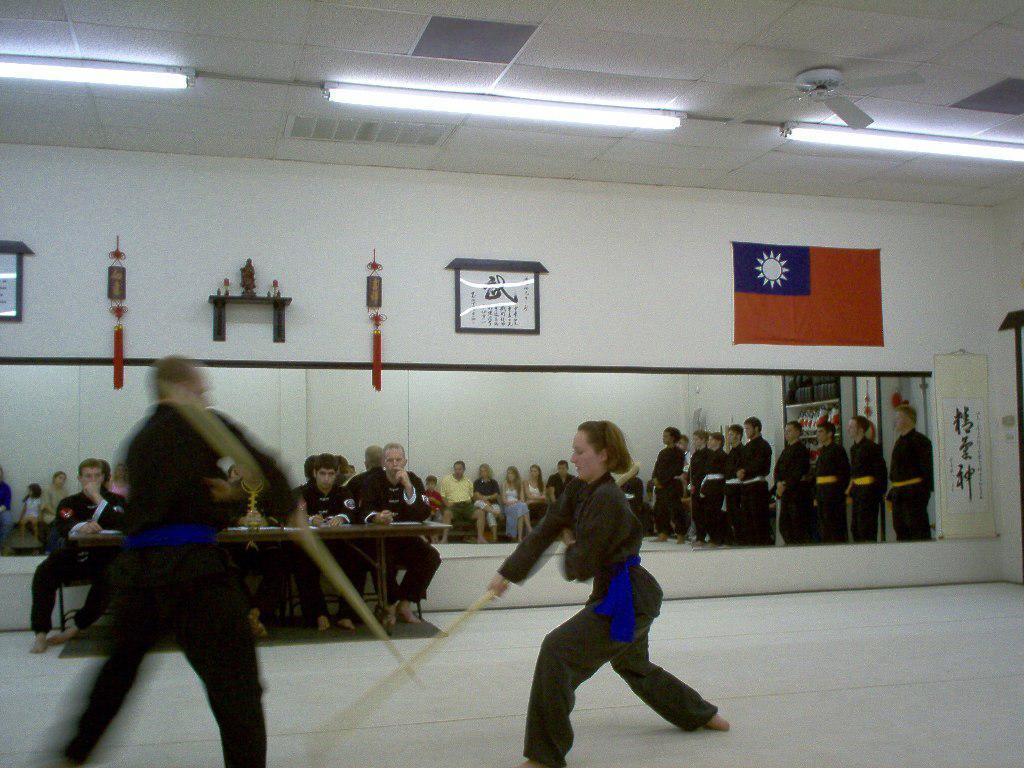How would you summarize this image in a sentence or two? In this image there is a man and a woman holding a stick in their hand are performing a martial art, beside them on the wall there is a mirror, in the mirror, we can see the reflection of a few people standing and sitting, at the top of the mirror there are a few objects and a flag, at the top of the image on the ceiling there are lights and a fan. 